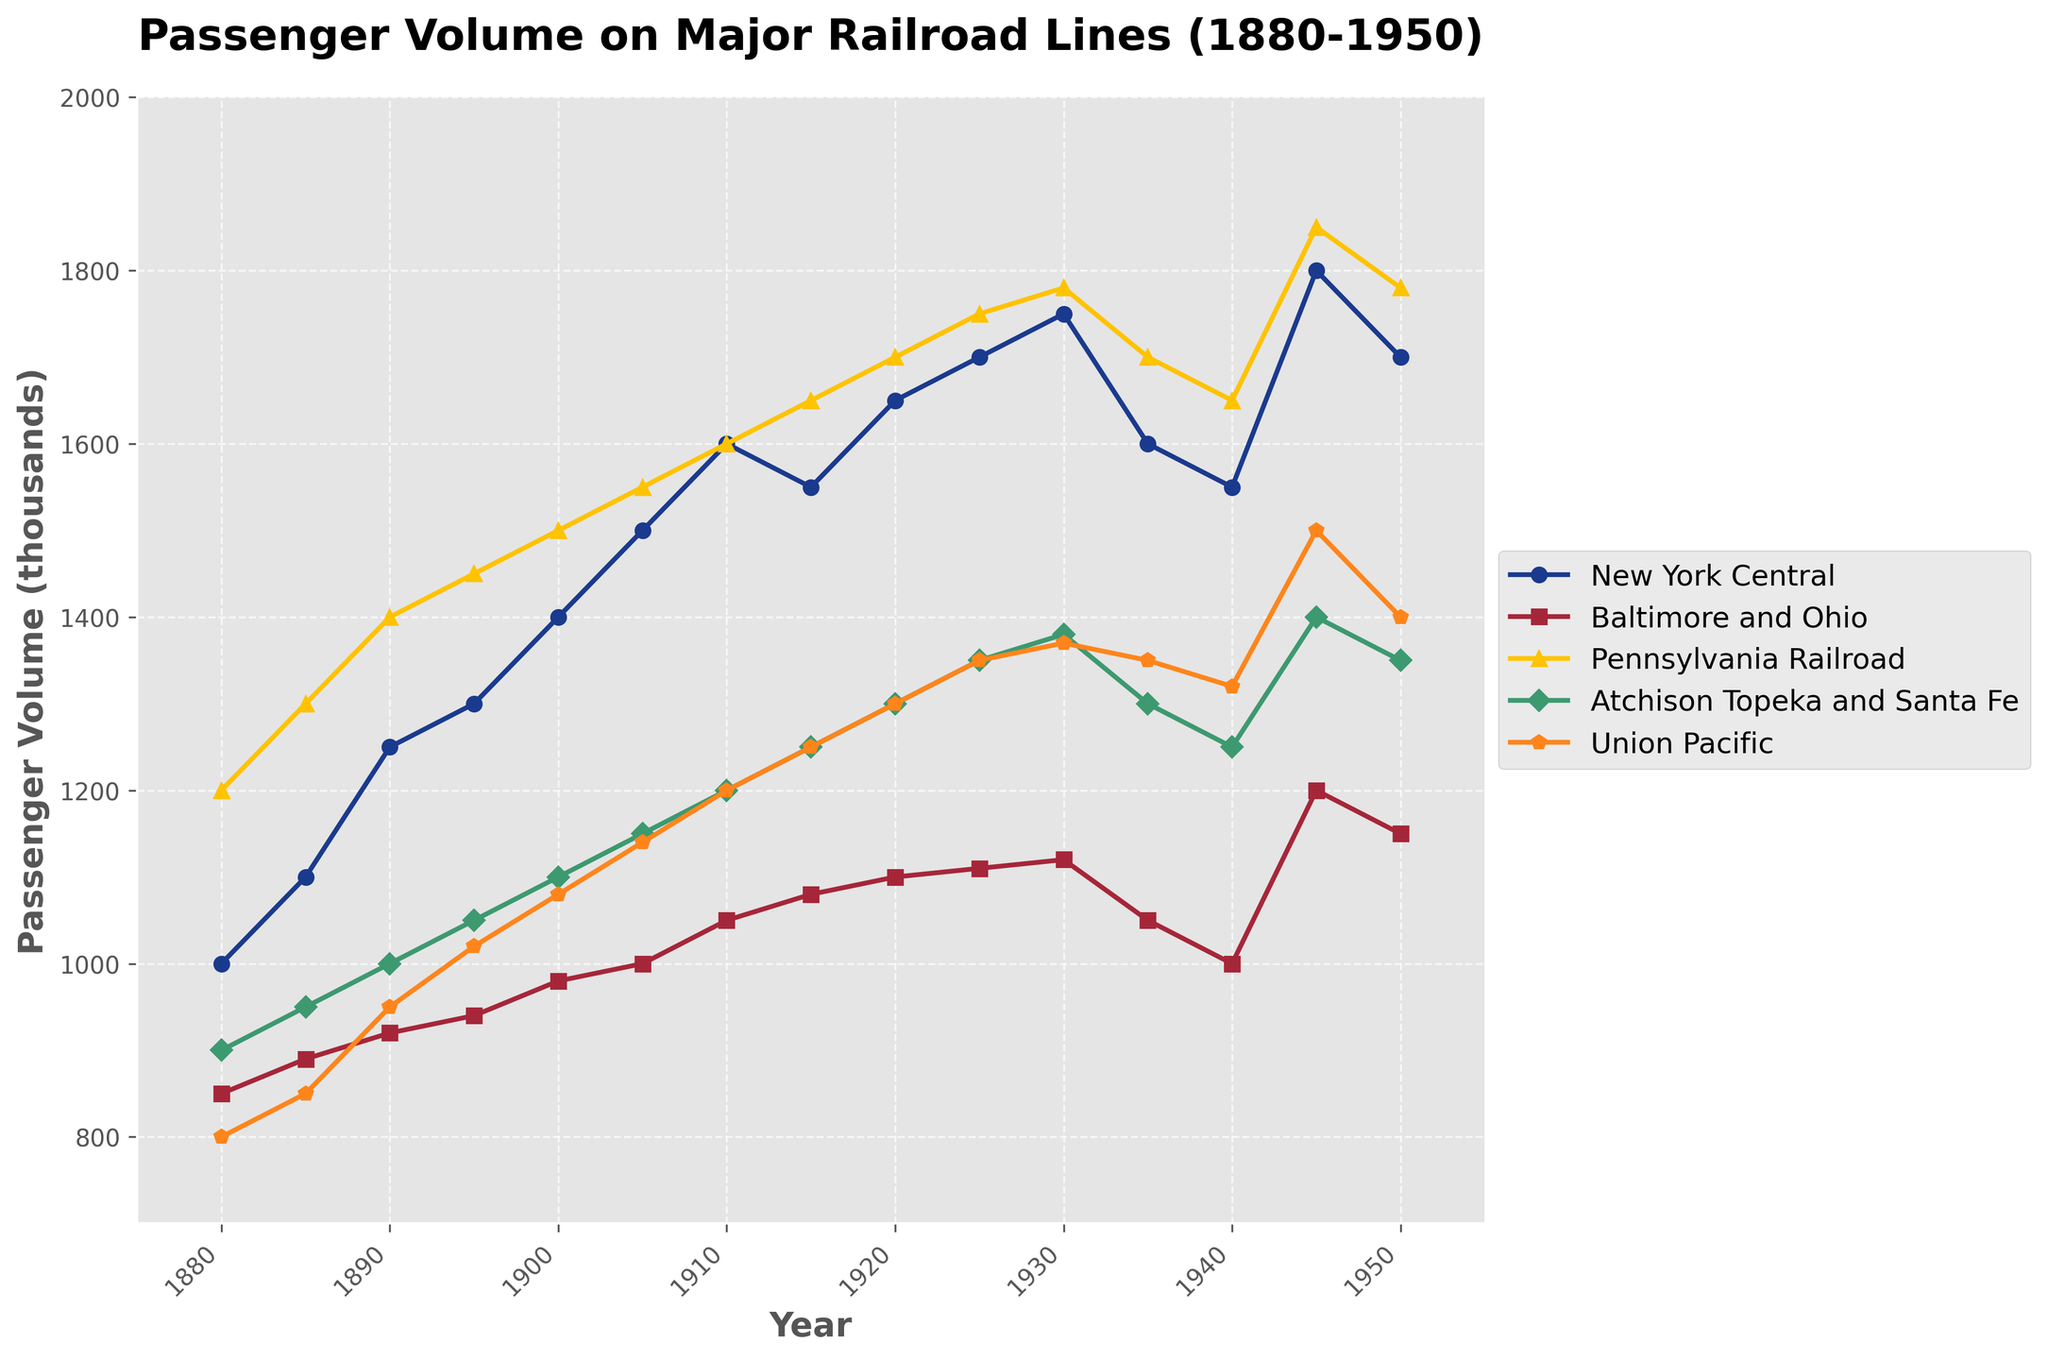What's the title of the plot? The title is typically the largest text at the top of the figure, meant to describe the main purpose or content of the plot. In this case, it reads 'Passenger Volume on Major Railroad Lines (1880-1950)'.
Answer: Passenger Volume on Major Railroad Lines (1880-1950) What does the x-axis represent? The x-axis typically represents the variable corresponding to the horizontal line. In this figure, the x-axis represents 'Year'.
Answer: Year Which railroad line had the highest passenger volume in 1945? To determine this, you need to look at the passenger volumes for all railroad lines in 1945 and identify the highest value. For 1945, the New York Central had 1800, Baltimore and Ohio had 1200, Pennsylvania Railroad had 1850, Atchison Topeka and Santa Fe had 1400, and Union Pacific had 1500. The highest value is 1850 from the Pennsylvania Railroad.
Answer: Pennsylvania Railroad How did the passenger volume of the New York Central change from 1880 to 1950? To understand the change, compare the passenger volumes of the New York Central in 1880 and 1950. In 1880, it was 1000, and in 1950, it was 1700. The change is 1700 - 1000 = 700.
Answer: Increased by 700 Which two railroad lines have the closest passenger volumes in 1930? To find this, compare the passenger volumes of all lines in 1930: New York Central (1750), Baltimore and Ohio (1120), Pennsylvania Railroad (1780), Atchison Topeka and Santa Fe (1380), and Union Pacific (1370). The closest values are for the Atchison Topeka and Santa Fe (1380) and Union Pacific (1370). The difference is 1380 - 1370 = 10.
Answer: Atchison Topeka and Santa Fe and Union Pacific What’s the average passenger volume for the Union Pacific in the first three decades (1880-1910)? To find the average, sum the passenger volumes for Union Pacific from 1880 (800), 1890 (950), and 1910 (1200), then divide by the number of years. The sum is 800 + 950 + 1200 = 2950. Dividing by 3 gives 2950 / 3 ≈ 983.33.
Answer: 983.33 Did any railroad line experience a decline in passenger volume from 1945 to 1950? If so, which one(s)? To answer this, compare the passenger volumes in 1945 and 1950 for all lines. New York Central (1800 to 1700), Baltimore and Ohio (1200 to 1150), Pennsylvania Railroad (1850 to 1780), Atchison Topeka and Santa Fe (1400 to 1350), and Union Pacific (1500 to 1400). All lines experienced a decline in this period.
Answer: All lines experienced a decline How many years did the passenger volume of the Pennsylvania Railroad consistently increase? To determine this, look at the passenger volume values for Pennsylvania Railroad and see how many consecutive years have increasing values. From 1880 to 1930, there is a consistent increase without any decline.
Answer: 50 years What's the total passenger volume for Baltimore and Ohio in 1900 and 1905 combined? Add the passenger volumes for Baltimore and Ohio in 1900 (980) and 1905 (1000). The total is 980 + 1000 = 1980.
Answer: 1980 Which railroad line had the highest peak passenger volume, and what was the value? Identify the peak passenger values for each railroad line and find the highest among them. New York Central (1800 in 1945), Baltimore and Ohio (1200 in 1945), Pennsylvania Railroad (1850 in 1945), Atchison Topeka and Santa Fe (1400 in 1945), Union Pacific (1500 in 1945). The highest is Pennsylvania Railroad with 1850 in 1945.
Answer: Pennsylvania Railroad, 1850 